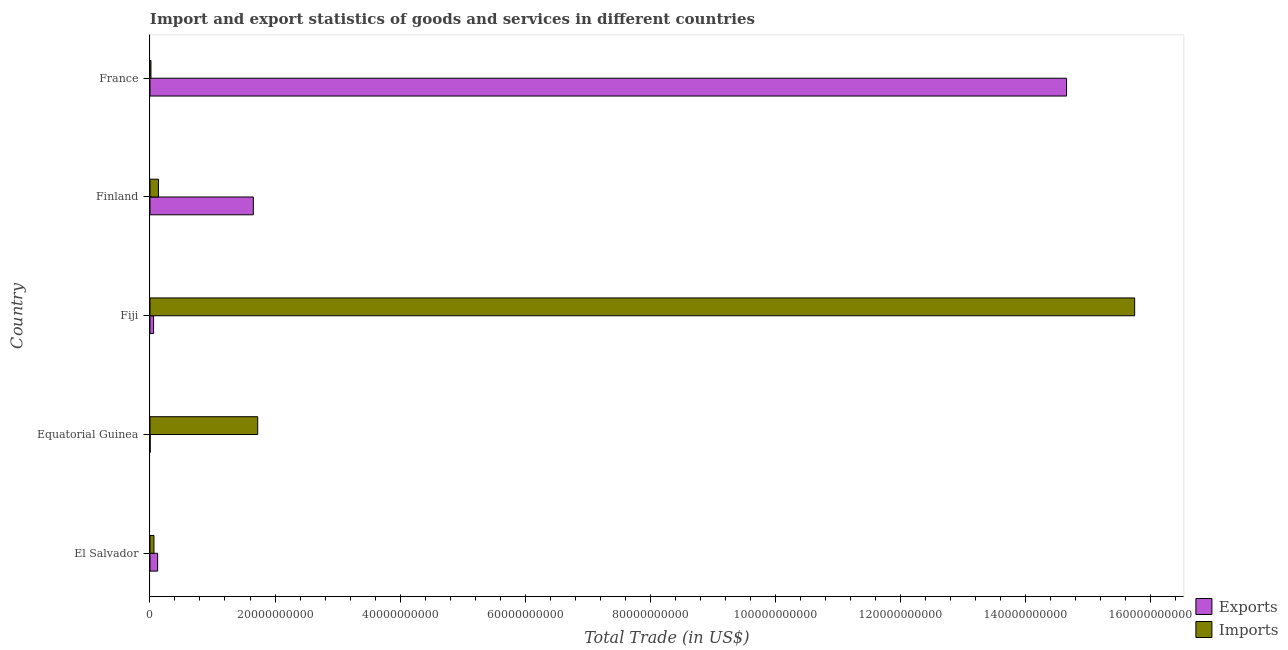How many groups of bars are there?
Your answer should be compact. 5. How many bars are there on the 5th tick from the bottom?
Offer a very short reply. 2. What is the imports of goods and services in El Salvador?
Your answer should be compact. 6.34e+08. Across all countries, what is the maximum imports of goods and services?
Your response must be concise. 1.58e+11. Across all countries, what is the minimum imports of goods and services?
Your answer should be very brief. 1.53e+08. In which country was the imports of goods and services maximum?
Your answer should be compact. Fiji. In which country was the export of goods and services minimum?
Ensure brevity in your answer.  Equatorial Guinea. What is the total imports of goods and services in the graph?
Your response must be concise. 1.77e+11. What is the difference between the export of goods and services in El Salvador and that in Finland?
Keep it short and to the point. -1.53e+1. What is the difference between the export of goods and services in Fiji and the imports of goods and services in Finland?
Make the answer very short. -7.79e+08. What is the average imports of goods and services per country?
Your answer should be very brief. 3.54e+1. What is the difference between the export of goods and services and imports of goods and services in France?
Make the answer very short. 1.46e+11. In how many countries, is the imports of goods and services greater than 148000000000 US$?
Offer a terse response. 1. What is the ratio of the imports of goods and services in El Salvador to that in France?
Your response must be concise. 4.13. What is the difference between the highest and the second highest imports of goods and services?
Offer a very short reply. 1.40e+11. What is the difference between the highest and the lowest export of goods and services?
Your answer should be very brief. 1.47e+11. Is the sum of the imports of goods and services in Fiji and Finland greater than the maximum export of goods and services across all countries?
Offer a terse response. Yes. What does the 1st bar from the top in Equatorial Guinea represents?
Your response must be concise. Imports. What does the 2nd bar from the bottom in Fiji represents?
Your answer should be very brief. Imports. How many bars are there?
Offer a very short reply. 10. How many countries are there in the graph?
Your answer should be compact. 5. Does the graph contain any zero values?
Provide a succinct answer. No. Does the graph contain grids?
Provide a succinct answer. No. Where does the legend appear in the graph?
Provide a short and direct response. Bottom right. How many legend labels are there?
Give a very brief answer. 2. How are the legend labels stacked?
Ensure brevity in your answer.  Vertical. What is the title of the graph?
Your answer should be very brief. Import and export statistics of goods and services in different countries. What is the label or title of the X-axis?
Your answer should be compact. Total Trade (in US$). What is the Total Trade (in US$) in Exports in El Salvador?
Give a very brief answer. 1.22e+09. What is the Total Trade (in US$) in Imports in El Salvador?
Ensure brevity in your answer.  6.34e+08. What is the Total Trade (in US$) in Exports in Equatorial Guinea?
Ensure brevity in your answer.  2.57e+07. What is the Total Trade (in US$) of Imports in Equatorial Guinea?
Your response must be concise. 1.72e+1. What is the Total Trade (in US$) of Exports in Fiji?
Give a very brief answer. 5.75e+08. What is the Total Trade (in US$) in Imports in Fiji?
Your response must be concise. 1.58e+11. What is the Total Trade (in US$) of Exports in Finland?
Your response must be concise. 1.65e+1. What is the Total Trade (in US$) in Imports in Finland?
Make the answer very short. 1.35e+09. What is the Total Trade (in US$) of Exports in France?
Offer a terse response. 1.47e+11. What is the Total Trade (in US$) of Imports in France?
Provide a short and direct response. 1.53e+08. Across all countries, what is the maximum Total Trade (in US$) in Exports?
Provide a short and direct response. 1.47e+11. Across all countries, what is the maximum Total Trade (in US$) in Imports?
Keep it short and to the point. 1.58e+11. Across all countries, what is the minimum Total Trade (in US$) of Exports?
Your response must be concise. 2.57e+07. Across all countries, what is the minimum Total Trade (in US$) in Imports?
Your answer should be very brief. 1.53e+08. What is the total Total Trade (in US$) in Exports in the graph?
Offer a terse response. 1.65e+11. What is the total Total Trade (in US$) in Imports in the graph?
Offer a terse response. 1.77e+11. What is the difference between the Total Trade (in US$) in Exports in El Salvador and that in Equatorial Guinea?
Make the answer very short. 1.20e+09. What is the difference between the Total Trade (in US$) in Imports in El Salvador and that in Equatorial Guinea?
Provide a succinct answer. -1.66e+1. What is the difference between the Total Trade (in US$) of Exports in El Salvador and that in Fiji?
Ensure brevity in your answer.  6.46e+08. What is the difference between the Total Trade (in US$) in Imports in El Salvador and that in Fiji?
Your answer should be very brief. -1.57e+11. What is the difference between the Total Trade (in US$) in Exports in El Salvador and that in Finland?
Provide a short and direct response. -1.53e+1. What is the difference between the Total Trade (in US$) of Imports in El Salvador and that in Finland?
Your response must be concise. -7.20e+08. What is the difference between the Total Trade (in US$) of Exports in El Salvador and that in France?
Ensure brevity in your answer.  -1.45e+11. What is the difference between the Total Trade (in US$) of Imports in El Salvador and that in France?
Offer a terse response. 4.81e+08. What is the difference between the Total Trade (in US$) of Exports in Equatorial Guinea and that in Fiji?
Provide a short and direct response. -5.49e+08. What is the difference between the Total Trade (in US$) of Imports in Equatorial Guinea and that in Fiji?
Your response must be concise. -1.40e+11. What is the difference between the Total Trade (in US$) of Exports in Equatorial Guinea and that in Finland?
Make the answer very short. -1.65e+1. What is the difference between the Total Trade (in US$) in Imports in Equatorial Guinea and that in Finland?
Make the answer very short. 1.59e+1. What is the difference between the Total Trade (in US$) in Exports in Equatorial Guinea and that in France?
Your answer should be very brief. -1.47e+11. What is the difference between the Total Trade (in US$) of Imports in Equatorial Guinea and that in France?
Provide a short and direct response. 1.71e+1. What is the difference between the Total Trade (in US$) in Exports in Fiji and that in Finland?
Provide a short and direct response. -1.60e+1. What is the difference between the Total Trade (in US$) in Imports in Fiji and that in Finland?
Make the answer very short. 1.56e+11. What is the difference between the Total Trade (in US$) in Exports in Fiji and that in France?
Your response must be concise. -1.46e+11. What is the difference between the Total Trade (in US$) in Imports in Fiji and that in France?
Your answer should be very brief. 1.57e+11. What is the difference between the Total Trade (in US$) of Exports in Finland and that in France?
Keep it short and to the point. -1.30e+11. What is the difference between the Total Trade (in US$) of Imports in Finland and that in France?
Provide a short and direct response. 1.20e+09. What is the difference between the Total Trade (in US$) of Exports in El Salvador and the Total Trade (in US$) of Imports in Equatorial Guinea?
Your answer should be very brief. -1.60e+1. What is the difference between the Total Trade (in US$) in Exports in El Salvador and the Total Trade (in US$) in Imports in Fiji?
Your response must be concise. -1.56e+11. What is the difference between the Total Trade (in US$) of Exports in El Salvador and the Total Trade (in US$) of Imports in Finland?
Keep it short and to the point. -1.33e+08. What is the difference between the Total Trade (in US$) in Exports in El Salvador and the Total Trade (in US$) in Imports in France?
Give a very brief answer. 1.07e+09. What is the difference between the Total Trade (in US$) in Exports in Equatorial Guinea and the Total Trade (in US$) in Imports in Fiji?
Offer a very short reply. -1.58e+11. What is the difference between the Total Trade (in US$) in Exports in Equatorial Guinea and the Total Trade (in US$) in Imports in Finland?
Make the answer very short. -1.33e+09. What is the difference between the Total Trade (in US$) of Exports in Equatorial Guinea and the Total Trade (in US$) of Imports in France?
Your response must be concise. -1.28e+08. What is the difference between the Total Trade (in US$) in Exports in Fiji and the Total Trade (in US$) in Imports in Finland?
Keep it short and to the point. -7.79e+08. What is the difference between the Total Trade (in US$) of Exports in Fiji and the Total Trade (in US$) of Imports in France?
Provide a succinct answer. 4.21e+08. What is the difference between the Total Trade (in US$) in Exports in Finland and the Total Trade (in US$) in Imports in France?
Offer a terse response. 1.64e+1. What is the average Total Trade (in US$) of Exports per country?
Your response must be concise. 3.30e+1. What is the average Total Trade (in US$) of Imports per country?
Offer a very short reply. 3.54e+1. What is the difference between the Total Trade (in US$) in Exports and Total Trade (in US$) in Imports in El Salvador?
Your response must be concise. 5.87e+08. What is the difference between the Total Trade (in US$) of Exports and Total Trade (in US$) of Imports in Equatorial Guinea?
Ensure brevity in your answer.  -1.72e+1. What is the difference between the Total Trade (in US$) in Exports and Total Trade (in US$) in Imports in Fiji?
Provide a short and direct response. -1.57e+11. What is the difference between the Total Trade (in US$) in Exports and Total Trade (in US$) in Imports in Finland?
Your answer should be compact. 1.52e+1. What is the difference between the Total Trade (in US$) of Exports and Total Trade (in US$) of Imports in France?
Give a very brief answer. 1.46e+11. What is the ratio of the Total Trade (in US$) in Exports in El Salvador to that in Equatorial Guinea?
Keep it short and to the point. 47.59. What is the ratio of the Total Trade (in US$) in Imports in El Salvador to that in Equatorial Guinea?
Provide a short and direct response. 0.04. What is the ratio of the Total Trade (in US$) of Exports in El Salvador to that in Fiji?
Ensure brevity in your answer.  2.12. What is the ratio of the Total Trade (in US$) in Imports in El Salvador to that in Fiji?
Keep it short and to the point. 0. What is the ratio of the Total Trade (in US$) of Exports in El Salvador to that in Finland?
Offer a very short reply. 0.07. What is the ratio of the Total Trade (in US$) of Imports in El Salvador to that in Finland?
Offer a very short reply. 0.47. What is the ratio of the Total Trade (in US$) of Exports in El Salvador to that in France?
Your answer should be compact. 0.01. What is the ratio of the Total Trade (in US$) in Imports in El Salvador to that in France?
Give a very brief answer. 4.13. What is the ratio of the Total Trade (in US$) in Exports in Equatorial Guinea to that in Fiji?
Ensure brevity in your answer.  0.04. What is the ratio of the Total Trade (in US$) in Imports in Equatorial Guinea to that in Fiji?
Offer a terse response. 0.11. What is the ratio of the Total Trade (in US$) in Exports in Equatorial Guinea to that in Finland?
Make the answer very short. 0. What is the ratio of the Total Trade (in US$) of Imports in Equatorial Guinea to that in Finland?
Keep it short and to the point. 12.73. What is the ratio of the Total Trade (in US$) of Imports in Equatorial Guinea to that in France?
Offer a terse response. 112.4. What is the ratio of the Total Trade (in US$) of Exports in Fiji to that in Finland?
Offer a terse response. 0.03. What is the ratio of the Total Trade (in US$) of Imports in Fiji to that in Finland?
Provide a succinct answer. 116.38. What is the ratio of the Total Trade (in US$) in Exports in Fiji to that in France?
Your answer should be very brief. 0. What is the ratio of the Total Trade (in US$) of Imports in Fiji to that in France?
Provide a succinct answer. 1027.5. What is the ratio of the Total Trade (in US$) of Exports in Finland to that in France?
Your answer should be very brief. 0.11. What is the ratio of the Total Trade (in US$) in Imports in Finland to that in France?
Provide a short and direct response. 8.83. What is the difference between the highest and the second highest Total Trade (in US$) in Exports?
Provide a succinct answer. 1.30e+11. What is the difference between the highest and the second highest Total Trade (in US$) of Imports?
Keep it short and to the point. 1.40e+11. What is the difference between the highest and the lowest Total Trade (in US$) of Exports?
Give a very brief answer. 1.47e+11. What is the difference between the highest and the lowest Total Trade (in US$) in Imports?
Provide a short and direct response. 1.57e+11. 